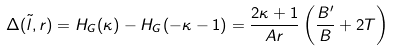<formula> <loc_0><loc_0><loc_500><loc_500>\Delta ( \tilde { l } , r ) = H _ { G } ( \kappa ) - H _ { G } ( - \kappa - 1 ) = \frac { 2 \kappa + 1 } { A r } \left ( \frac { B ^ { \prime } } { B } + 2 T \right )</formula> 